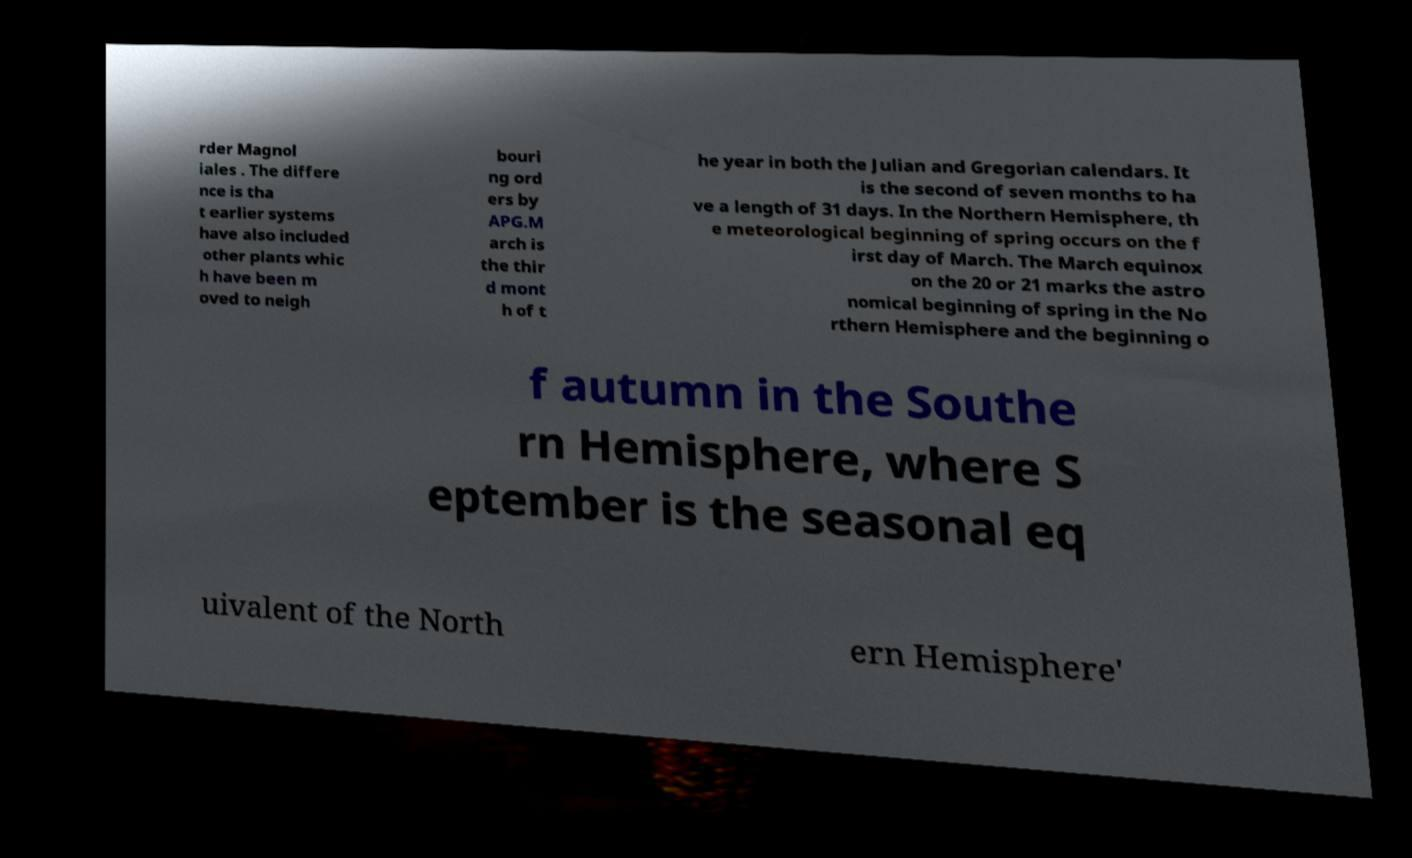I need the written content from this picture converted into text. Can you do that? rder Magnol iales . The differe nce is tha t earlier systems have also included other plants whic h have been m oved to neigh bouri ng ord ers by APG.M arch is the thir d mont h of t he year in both the Julian and Gregorian calendars. It is the second of seven months to ha ve a length of 31 days. In the Northern Hemisphere, th e meteorological beginning of spring occurs on the f irst day of March. The March equinox on the 20 or 21 marks the astro nomical beginning of spring in the No rthern Hemisphere and the beginning o f autumn in the Southe rn Hemisphere, where S eptember is the seasonal eq uivalent of the North ern Hemisphere' 